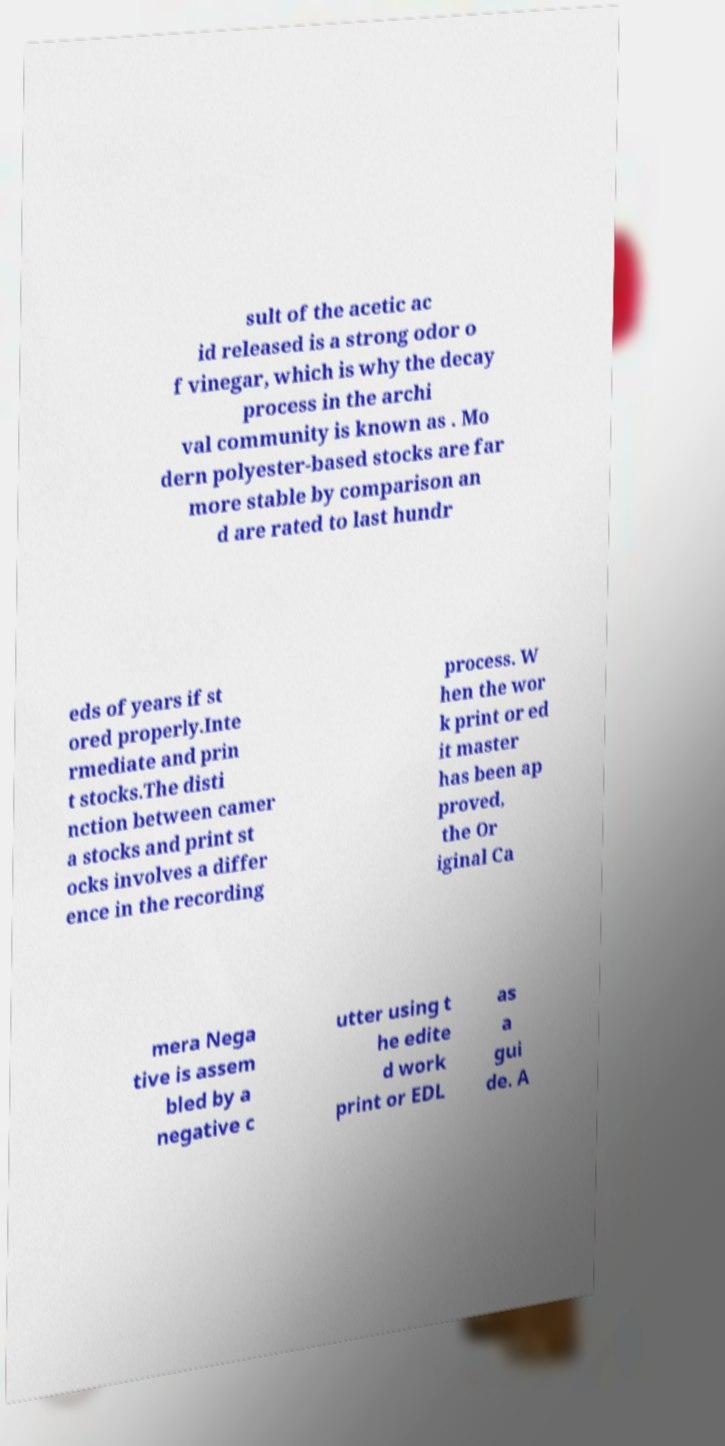What messages or text are displayed in this image? I need them in a readable, typed format. sult of the acetic ac id released is a strong odor o f vinegar, which is why the decay process in the archi val community is known as . Mo dern polyester-based stocks are far more stable by comparison an d are rated to last hundr eds of years if st ored properly.Inte rmediate and prin t stocks.The disti nction between camer a stocks and print st ocks involves a differ ence in the recording process. W hen the wor k print or ed it master has been ap proved, the Or iginal Ca mera Nega tive is assem bled by a negative c utter using t he edite d work print or EDL as a gui de. A 